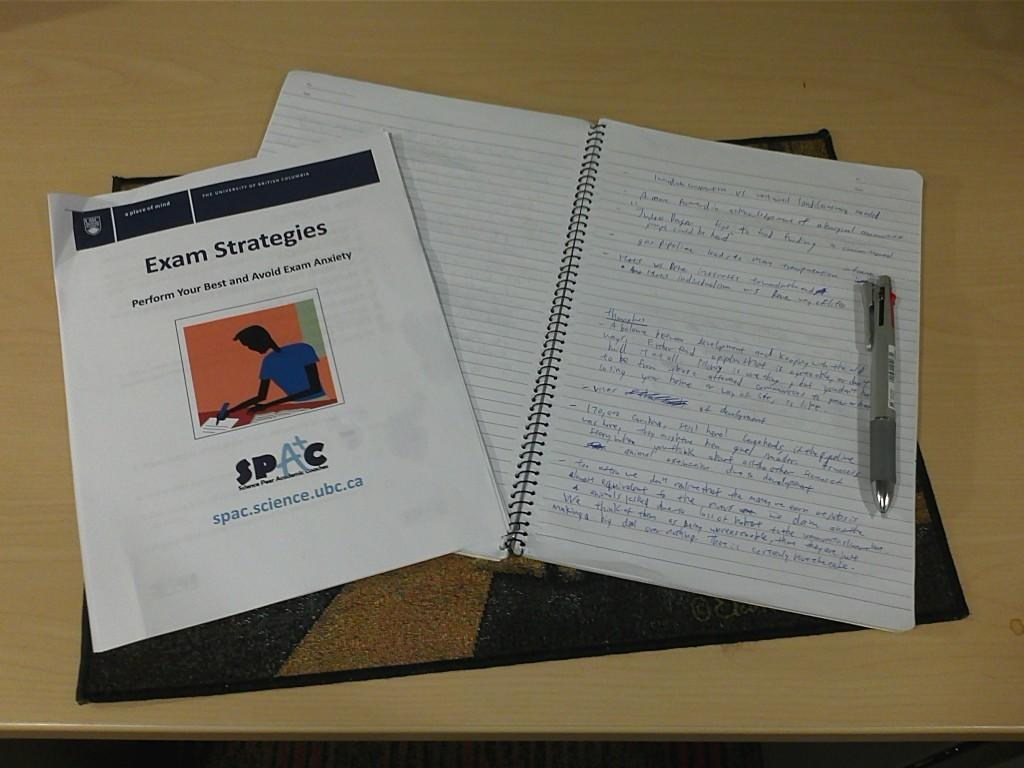What is the main object in the image? There is a book in the image. What can be seen next to the book? There is an ash-colored pen in the image. What else is present in the image besides the book and pen? There are papers in the image. What is the condition of the papers? Something is written on the papers. On what surface is the book placed? The book is on a brown-colored table. What type of milk is being poured into the actor's fear in the image? There is no actor, fear, or milk present in the image. 